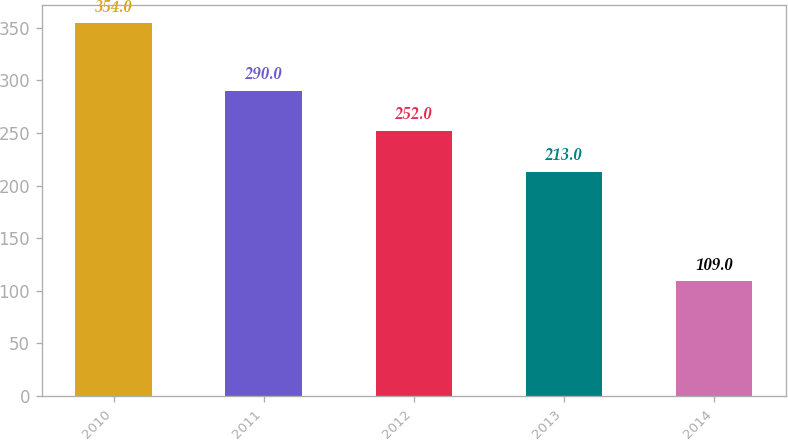Convert chart. <chart><loc_0><loc_0><loc_500><loc_500><bar_chart><fcel>2010<fcel>2011<fcel>2012<fcel>2013<fcel>2014<nl><fcel>354<fcel>290<fcel>252<fcel>213<fcel>109<nl></chart> 